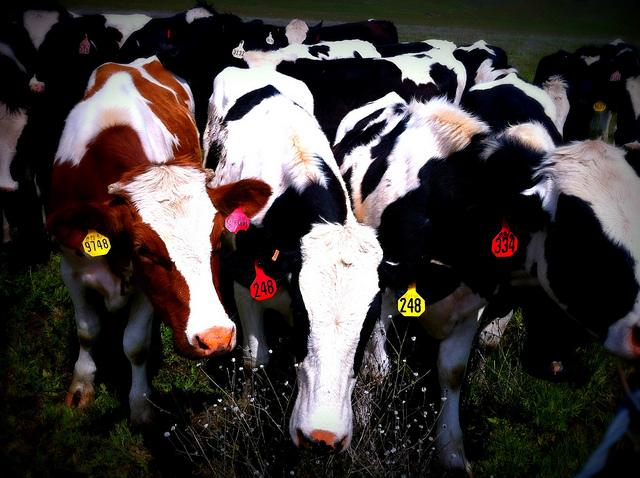What animals have the tags on them?

Choices:
A) dogs
B) cats
C) cows
D) horses cows 